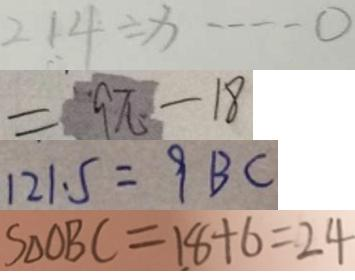Convert formula to latex. <formula><loc_0><loc_0><loc_500><loc_500>2 1 4 \div x \cdots 0 
 = 9 \pi - 1 8 
 1 2 1 . 5 = 9 B C 
 S _ { \Delta O B C } = 1 8 + 6 = 2 4</formula> 